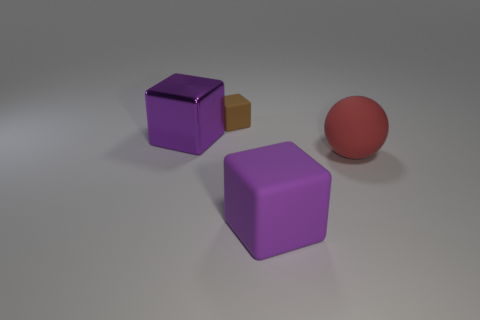Is there any other thing that has the same shape as the large red thing?
Give a very brief answer. No. The matte block in front of the red ball is what color?
Provide a short and direct response. Purple. Does the purple metal object have the same size as the rubber block that is in front of the red sphere?
Your answer should be very brief. Yes. There is a thing that is on the right side of the metallic thing and on the left side of the large rubber block; what size is it?
Your answer should be very brief. Small. Is there a tiny purple cylinder made of the same material as the small brown object?
Provide a succinct answer. No. What is the shape of the brown object?
Ensure brevity in your answer.  Cube. Is the size of the red sphere the same as the brown block?
Offer a terse response. No. How many other objects are the same shape as the big purple metal thing?
Make the answer very short. 2. What is the shape of the purple thing that is behind the sphere?
Offer a very short reply. Cube. There is a large object that is behind the red ball; does it have the same shape as the purple thing on the right side of the small matte thing?
Your response must be concise. Yes. 